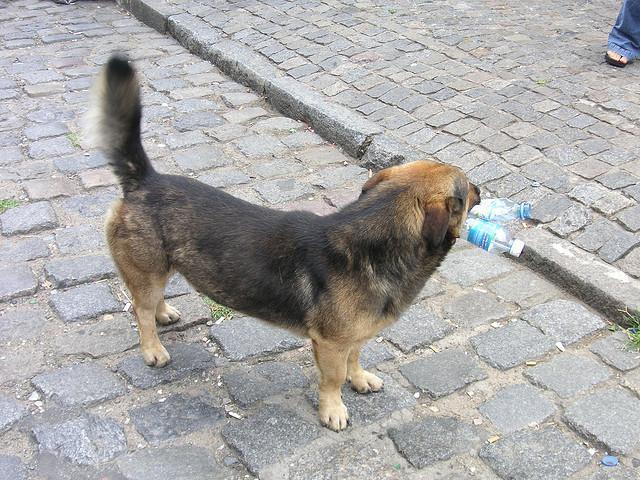What is in the dog's mouth?
From the following set of four choices, select the accurate answer to respond to the question.
Options: Nothing, bone, 2 bottles, water bottle. Nothing. 